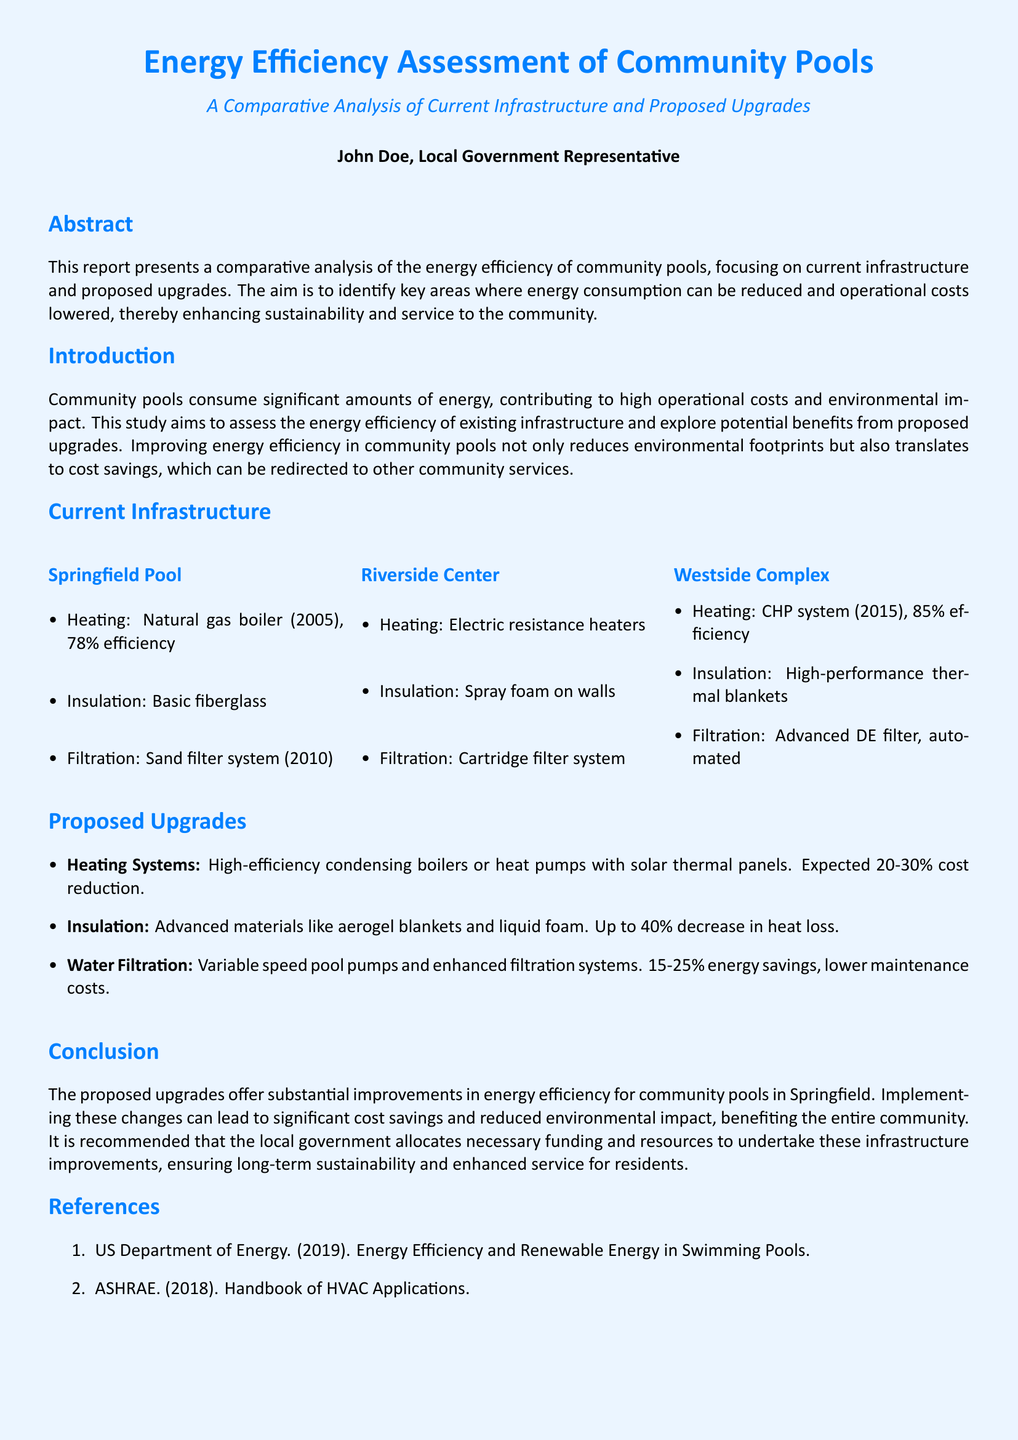What is the efficiency of the heating system at Springfield Pool? The Springfield Pool has a natural gas boiler from 2005 with an efficiency of 78%.
Answer: 78% What is the proposed percentage cost reduction for heating systems? The report suggests a proposed cost reduction of 20-30% for the new heating systems.
Answer: 20-30% What type of filtration system does Riverside Center currently use? Riverside Center currently utilizes an electric resistance heater and a cartridge filter system.
Answer: Cartridge filter system What is the maximum potential decrease in heat loss from the proposed insulation upgrades? The document states that advanced materials for insulation could achieve up to a 40% decrease in heat loss.
Answer: 40% What are the proposed upgrades for water filtration? The proposed upgrades include variable speed pool pumps and enhanced filtration systems.
Answer: Variable speed pool pumps and enhanced filtration systems How many community pools were assessed in the report? The report assesses three community pools: Springfield Pool, Riverside Center, and Westside Complex.
Answer: Three What type of heating system is used at Westside Complex? Westside Complex uses a CHP system from 2015 with 85% efficiency.
Answer: CHP system What is the purpose of this energy efficiency assessment report? The purpose of the report is to identify areas for reducing energy consumption and lowering operational costs.
Answer: Reduce energy consumption and lower operational costs 